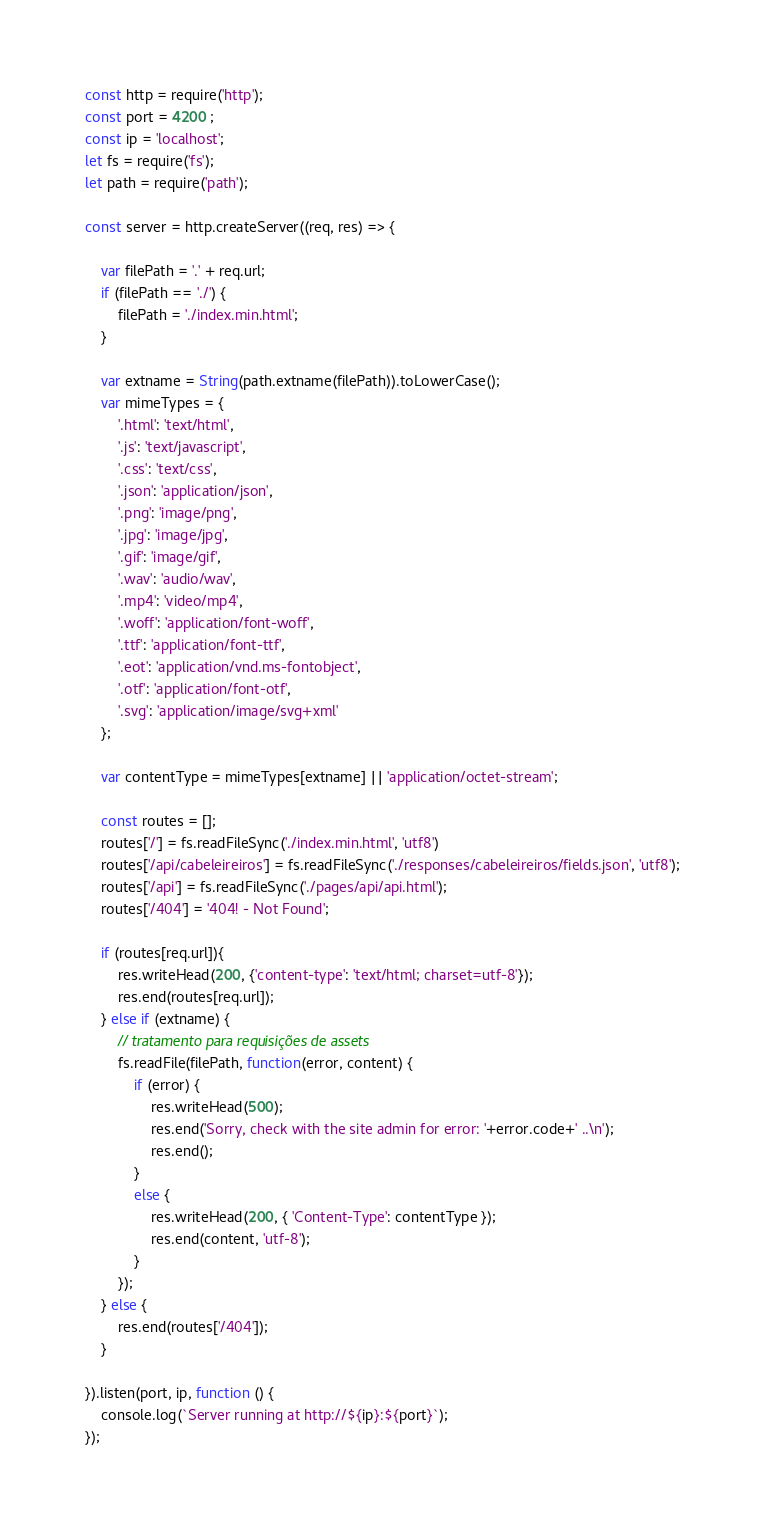Convert code to text. <code><loc_0><loc_0><loc_500><loc_500><_JavaScript_>const http = require('http');
const port = 4200 ;
const ip = 'localhost';
let fs = require('fs');
let path = require('path');

const server = http.createServer((req, res) => {

    var filePath = '.' + req.url;
    if (filePath == './') {
        filePath = './index.min.html';
    }

    var extname = String(path.extname(filePath)).toLowerCase();
    var mimeTypes = {
        '.html': 'text/html',
        '.js': 'text/javascript',
        '.css': 'text/css',
        '.json': 'application/json',
        '.png': 'image/png',
        '.jpg': 'image/jpg',
        '.gif': 'image/gif',
        '.wav': 'audio/wav',
        '.mp4': 'video/mp4',
        '.woff': 'application/font-woff',
        '.ttf': 'application/font-ttf',
        '.eot': 'application/vnd.ms-fontobject',
        '.otf': 'application/font-otf',
        '.svg': 'application/image/svg+xml'
    };

    var contentType = mimeTypes[extname] || 'application/octet-stream';

    const routes = [];
    routes['/'] = fs.readFileSync('./index.min.html', 'utf8')
    routes['/api/cabeleireiros'] = fs.readFileSync('./responses/cabeleireiros/fields.json', 'utf8');
    routes['/api'] = fs.readFileSync('./pages/api/api.html');
    routes['/404'] = '404! - Not Found';

    if (routes[req.url]){
        res.writeHead(200, {'content-type': 'text/html; charset=utf-8'});
        res.end(routes[req.url]);
    } else if (extname) {
        // tratamento para requisições de assets
        fs.readFile(filePath, function(error, content) {
            if (error) {
                res.writeHead(500);
                res.end('Sorry, check with the site admin for error: '+error.code+' ..\n');
                res.end();
            }
            else {
                res.writeHead(200, { 'Content-Type': contentType });
                res.end(content, 'utf-8');
            }
        });
    } else {
        res.end(routes['/404']);
    }
    
}).listen(port, ip, function () {
    console.log(`Server running at http://${ip}:${port}`);
});
</code> 